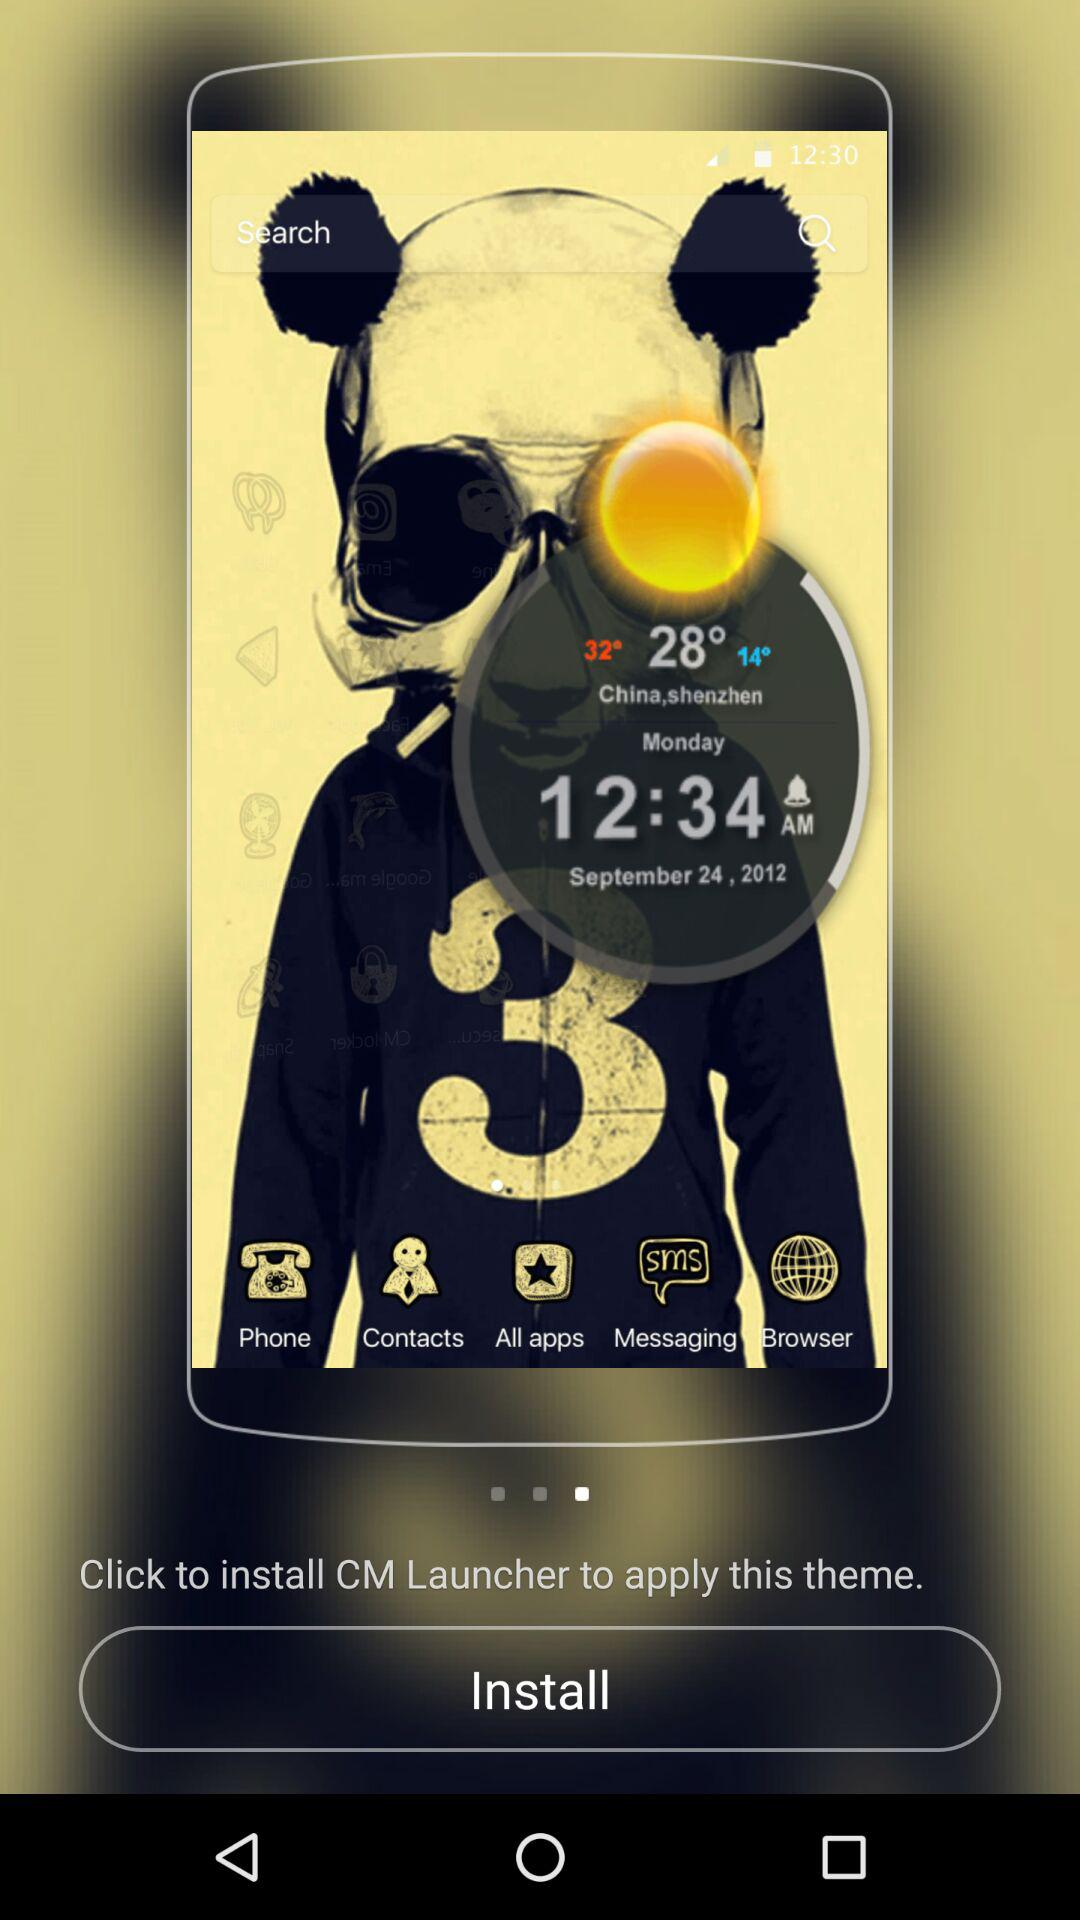To apply this theme, which launcher do I have to install? You have to install CM Launcher to apply this theme. 